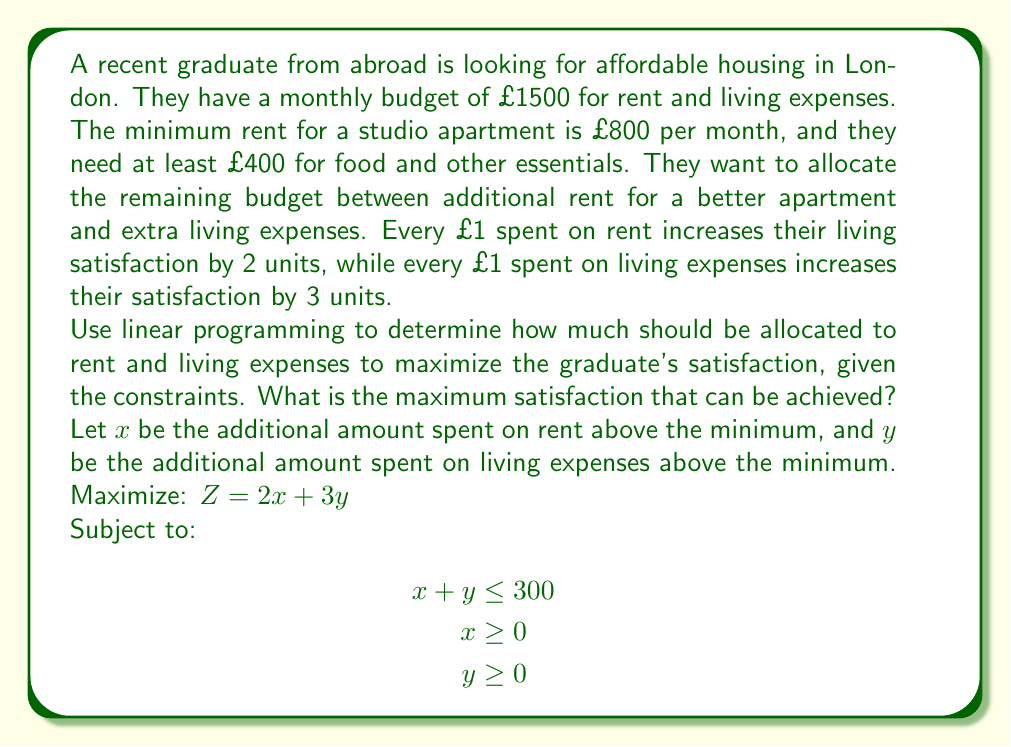What is the answer to this math problem? To solve this linear programming problem, we'll use the graphical method:

1) First, let's plot the constraints:
   - $x + y = 300$ (budget constraint)
   - $x = 0$ (y-axis)
   - $y = 0$ (x-axis)

2) The feasible region is the triangle formed by these lines in the first quadrant.

3) The objective function is $Z = 2x + 3y$. We need to find the point in the feasible region that maximizes this function.

4) The gradient of the objective function is (2, 3). This means that Z increases fastest in the direction (2, 3).

5) We can visualize this by drawing lines perpendicular to (2, 3), i.e., lines with slope -2/3. The optimal solution will be at the furthest of these lines that still touches the feasible region.

6) This occurs at the point where $x = 0$ and $y = 300$.

7) At this point:
   $Z = 2(0) + 3(300) = 900$

8) Therefore, the optimal solution is to allocate all the additional budget (£300) to living expenses.

9) The total budget allocation is:
   Rent: £800 (minimum) + £0 (additional) = £800
   Living expenses: £400 (minimum) + £300 (additional) = £700

10) The maximum satisfaction achieved is 900 units.
Answer: The optimal budget allocation is £800 for rent and £700 for living expenses. The maximum satisfaction that can be achieved is 900 units. 